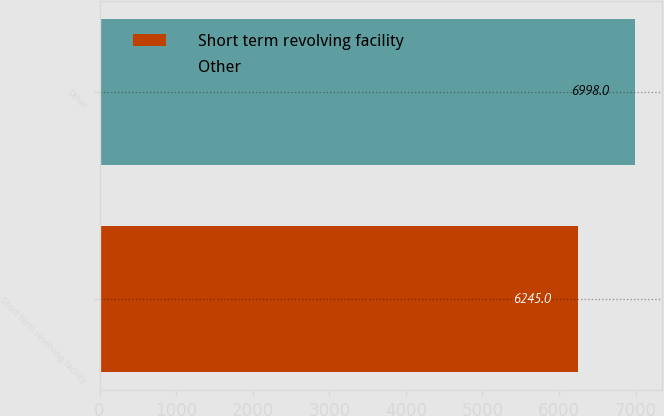<chart> <loc_0><loc_0><loc_500><loc_500><bar_chart><fcel>Short term revolving facility<fcel>Other<nl><fcel>6245<fcel>6998<nl></chart> 